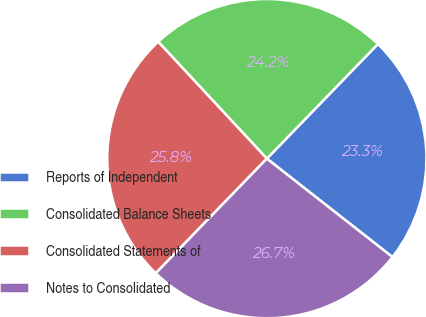Convert chart to OTSL. <chart><loc_0><loc_0><loc_500><loc_500><pie_chart><fcel>Reports of Independent<fcel>Consolidated Balance Sheets<fcel>Consolidated Statements of<fcel>Notes to Consolidated<nl><fcel>23.33%<fcel>24.17%<fcel>25.83%<fcel>26.67%<nl></chart> 